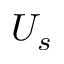Convert formula to latex. <formula><loc_0><loc_0><loc_500><loc_500>U _ { s }</formula> 